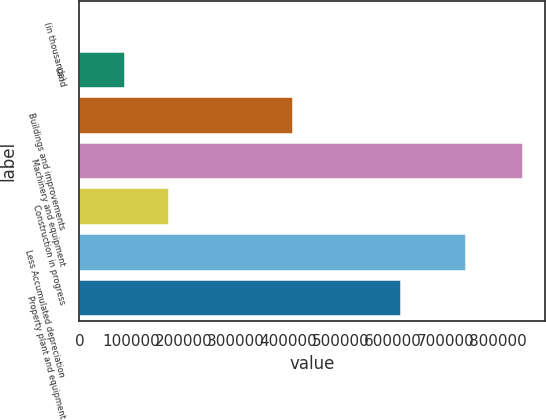Convert chart. <chart><loc_0><loc_0><loc_500><loc_500><bar_chart><fcel>(in thousands)<fcel>Land<fcel>Buildings and improvements<fcel>Machinery and equipment<fcel>Construction in progress<fcel>Less Accumulated depreciation<fcel>Property plant and equipment<nl><fcel>2012<fcel>86643.9<fcel>409451<fcel>848331<fcel>171276<fcel>739285<fcel>614705<nl></chart> 